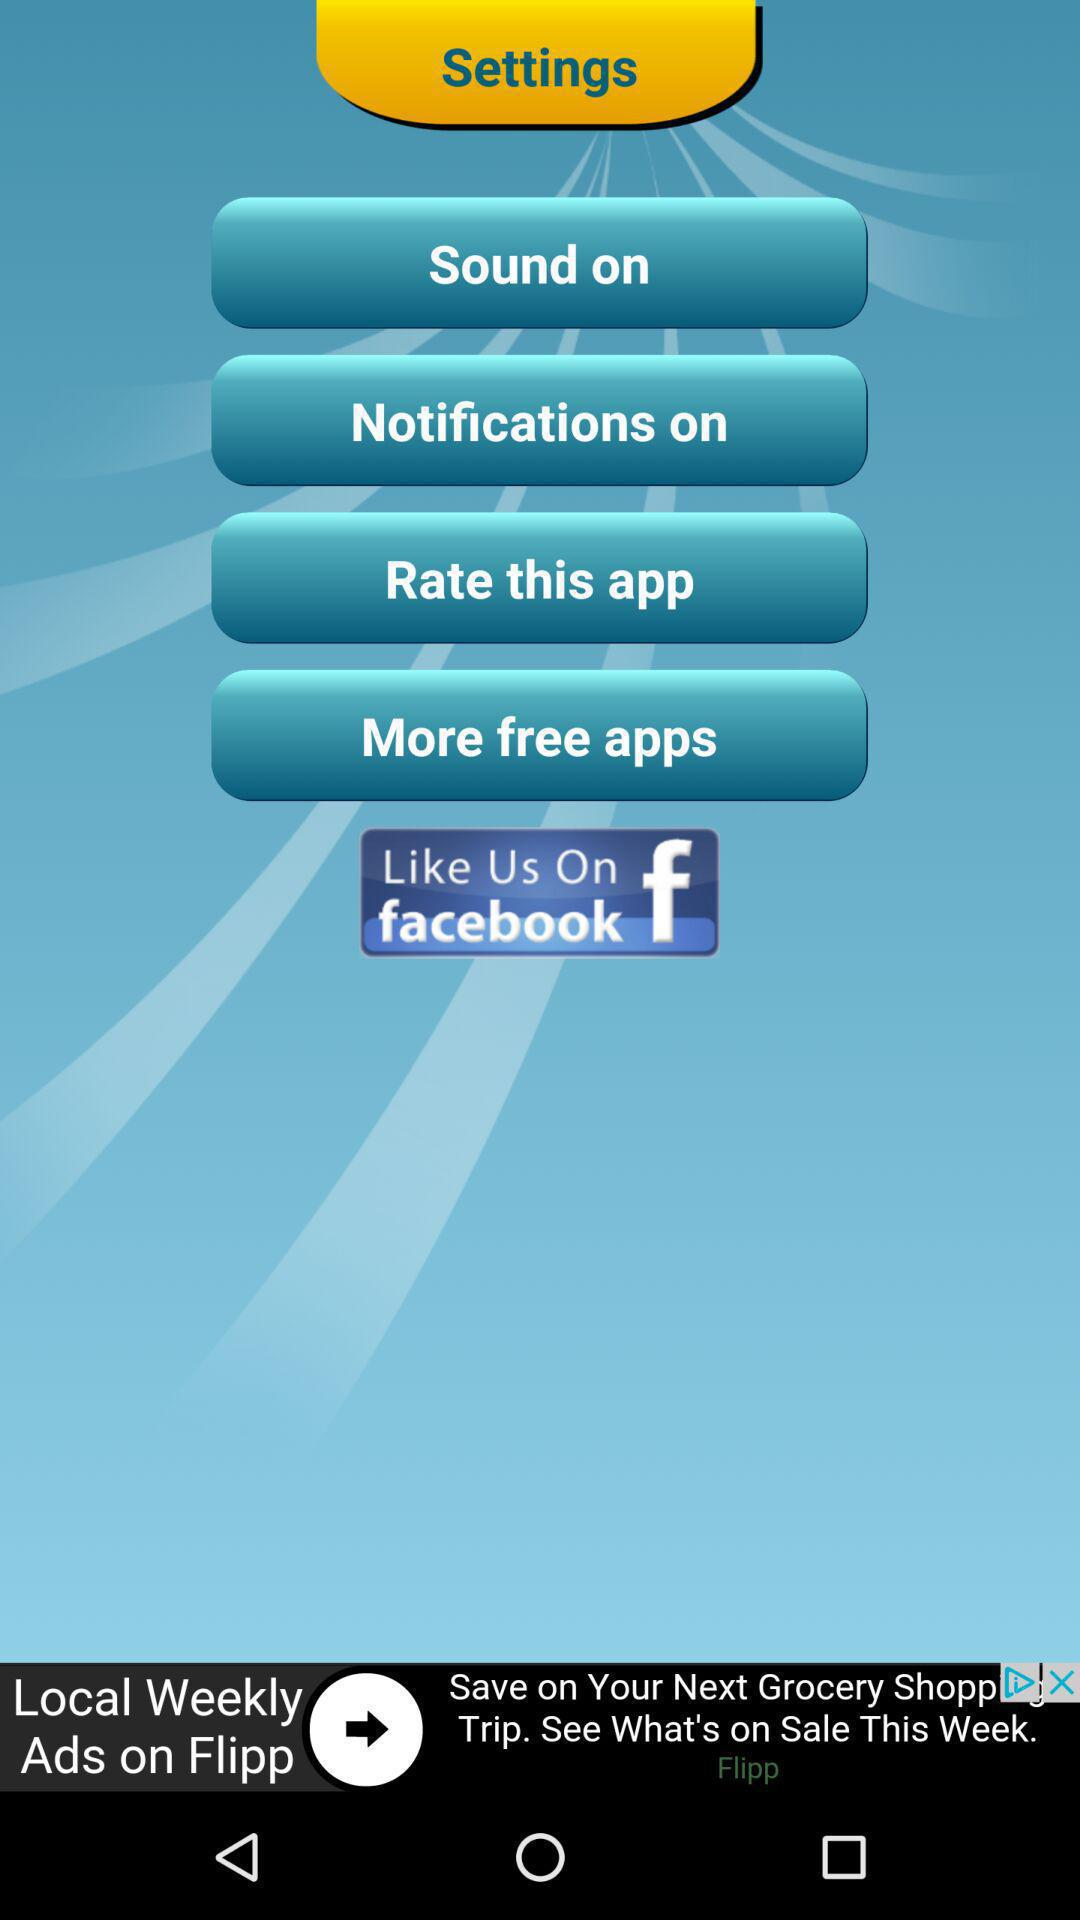How many local weekly ads are there on "Flipp"?
When the provided information is insufficient, respond with <no answer>. <no answer> 